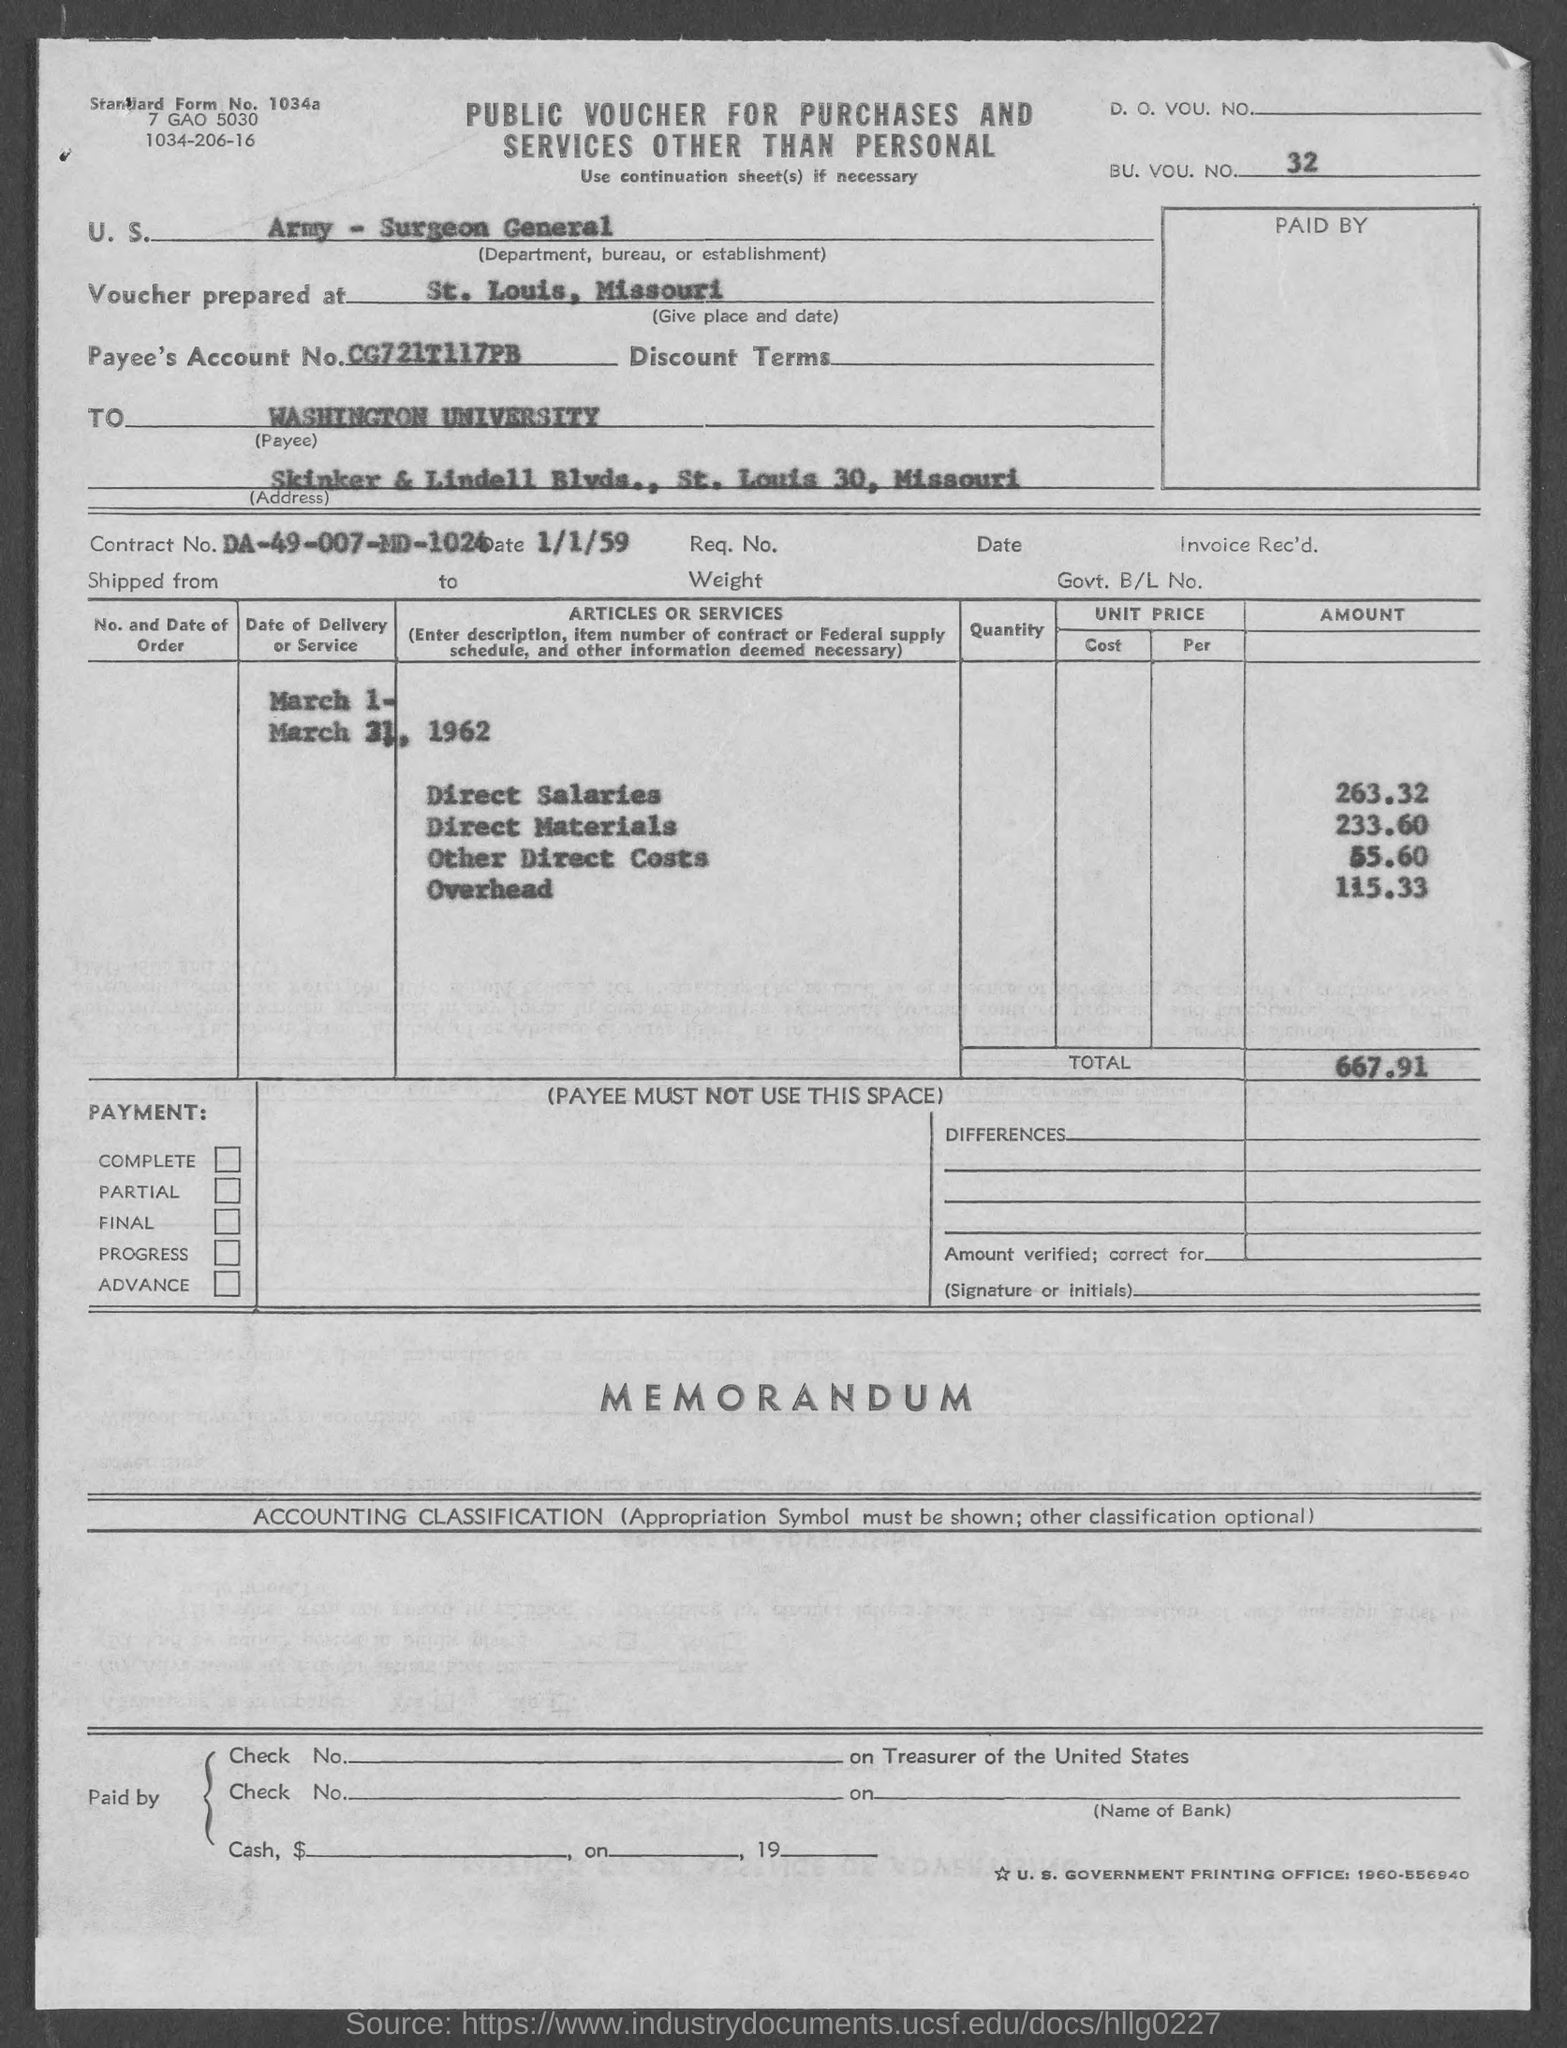Outline some significant characteristics in this image. The voucher was prepared in St. Louis, Missouri. The Contract No. is DA-49-007-MD-1024. The total amount is 667.91 dollars. The Surgeon General of the Army is a department, bureau, or establishment that is mentioned. This document is titled 'PUBLIC VOUCHER FOR PURCHASES AND SERVICES OTHER THAN PERSONAL.' 